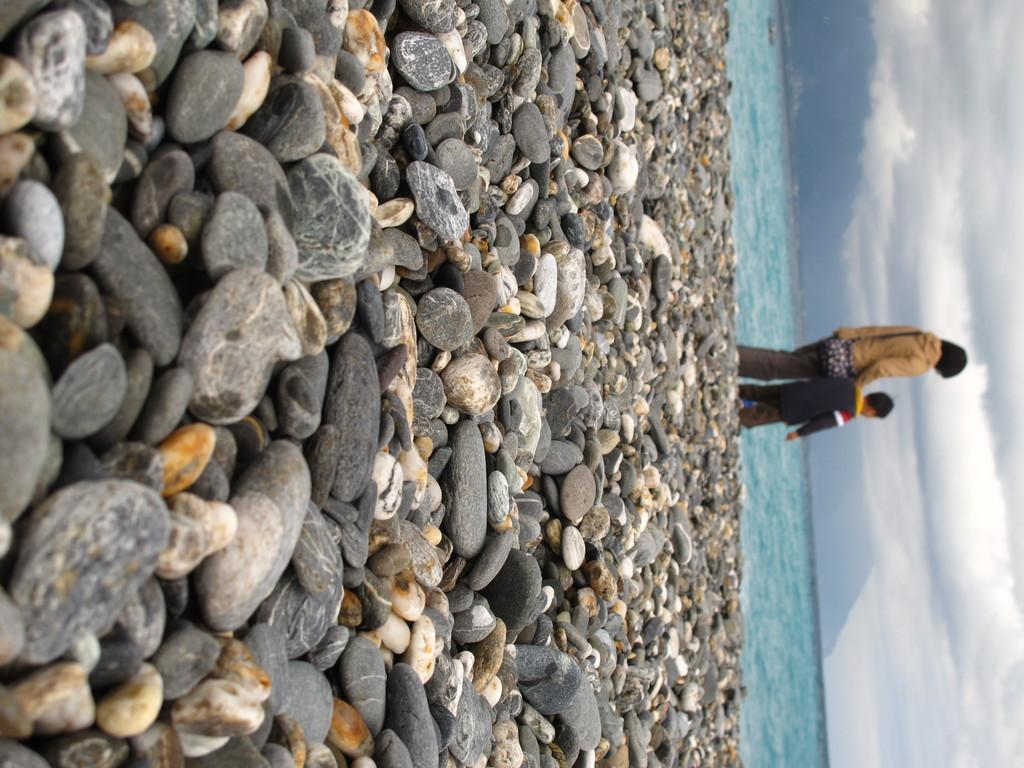What type of natural elements can be seen in the image? There are stones and water visible in the image. How many people are present in the image? There are two persons in the image. What is visible in the sky in the image? The sky is visible in the image, and there are clouds in the sky. What type of jewel can be seen on the window in the image? There is no jewel or window present in the image. What type of expansion is visible in the image? There is no expansion visible in the image; it features stones, water, two persons, and a sky with clouds. 